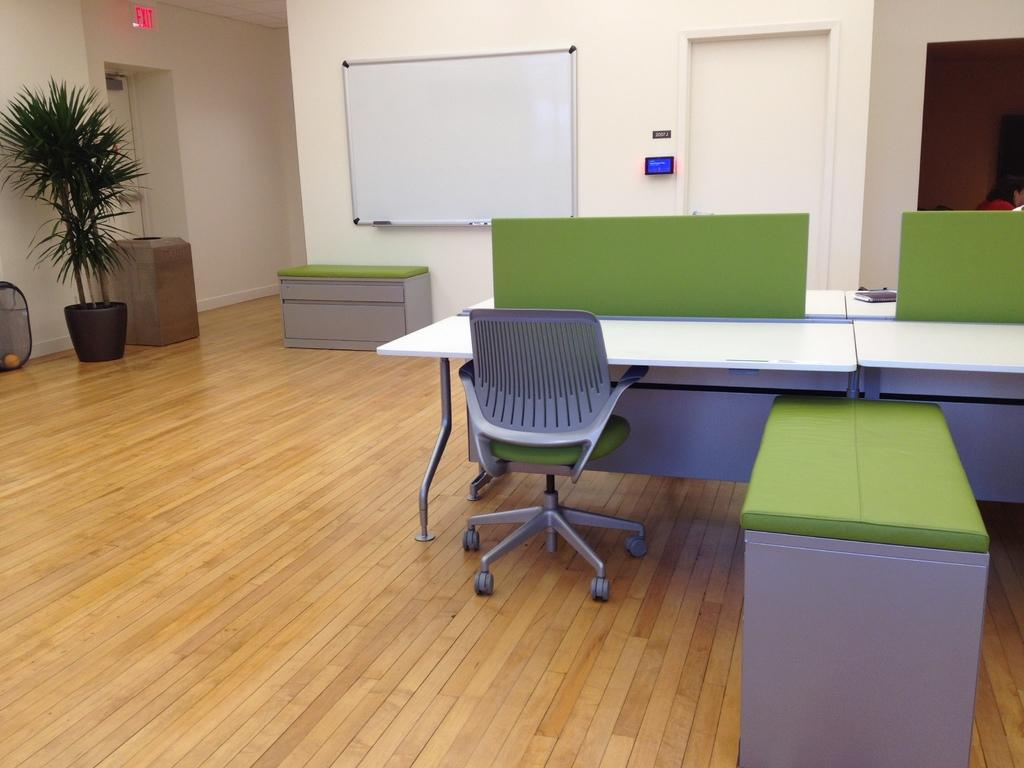What type of furniture is present in the image? There is a chair and a desk in the image. What is the floor made of in the image? The floor in the image is made of wood. What type of container is present in the image? There is a plant pot and a garbage bin in the image. What is used for writing or displaying information in the image? There is a white board and an instruction board in the image. What is the entrance/exit feature in the image? There is a door in the image. What type of wave can be seen crashing on the shore in the image? There is no wave or shore present in the image; it features a room with a chair, desk, wooden floor, plant pot, white board, door, and garbage bin. What type of suit is hanging in the closet in the image? There is no suit or closet present in the image. 